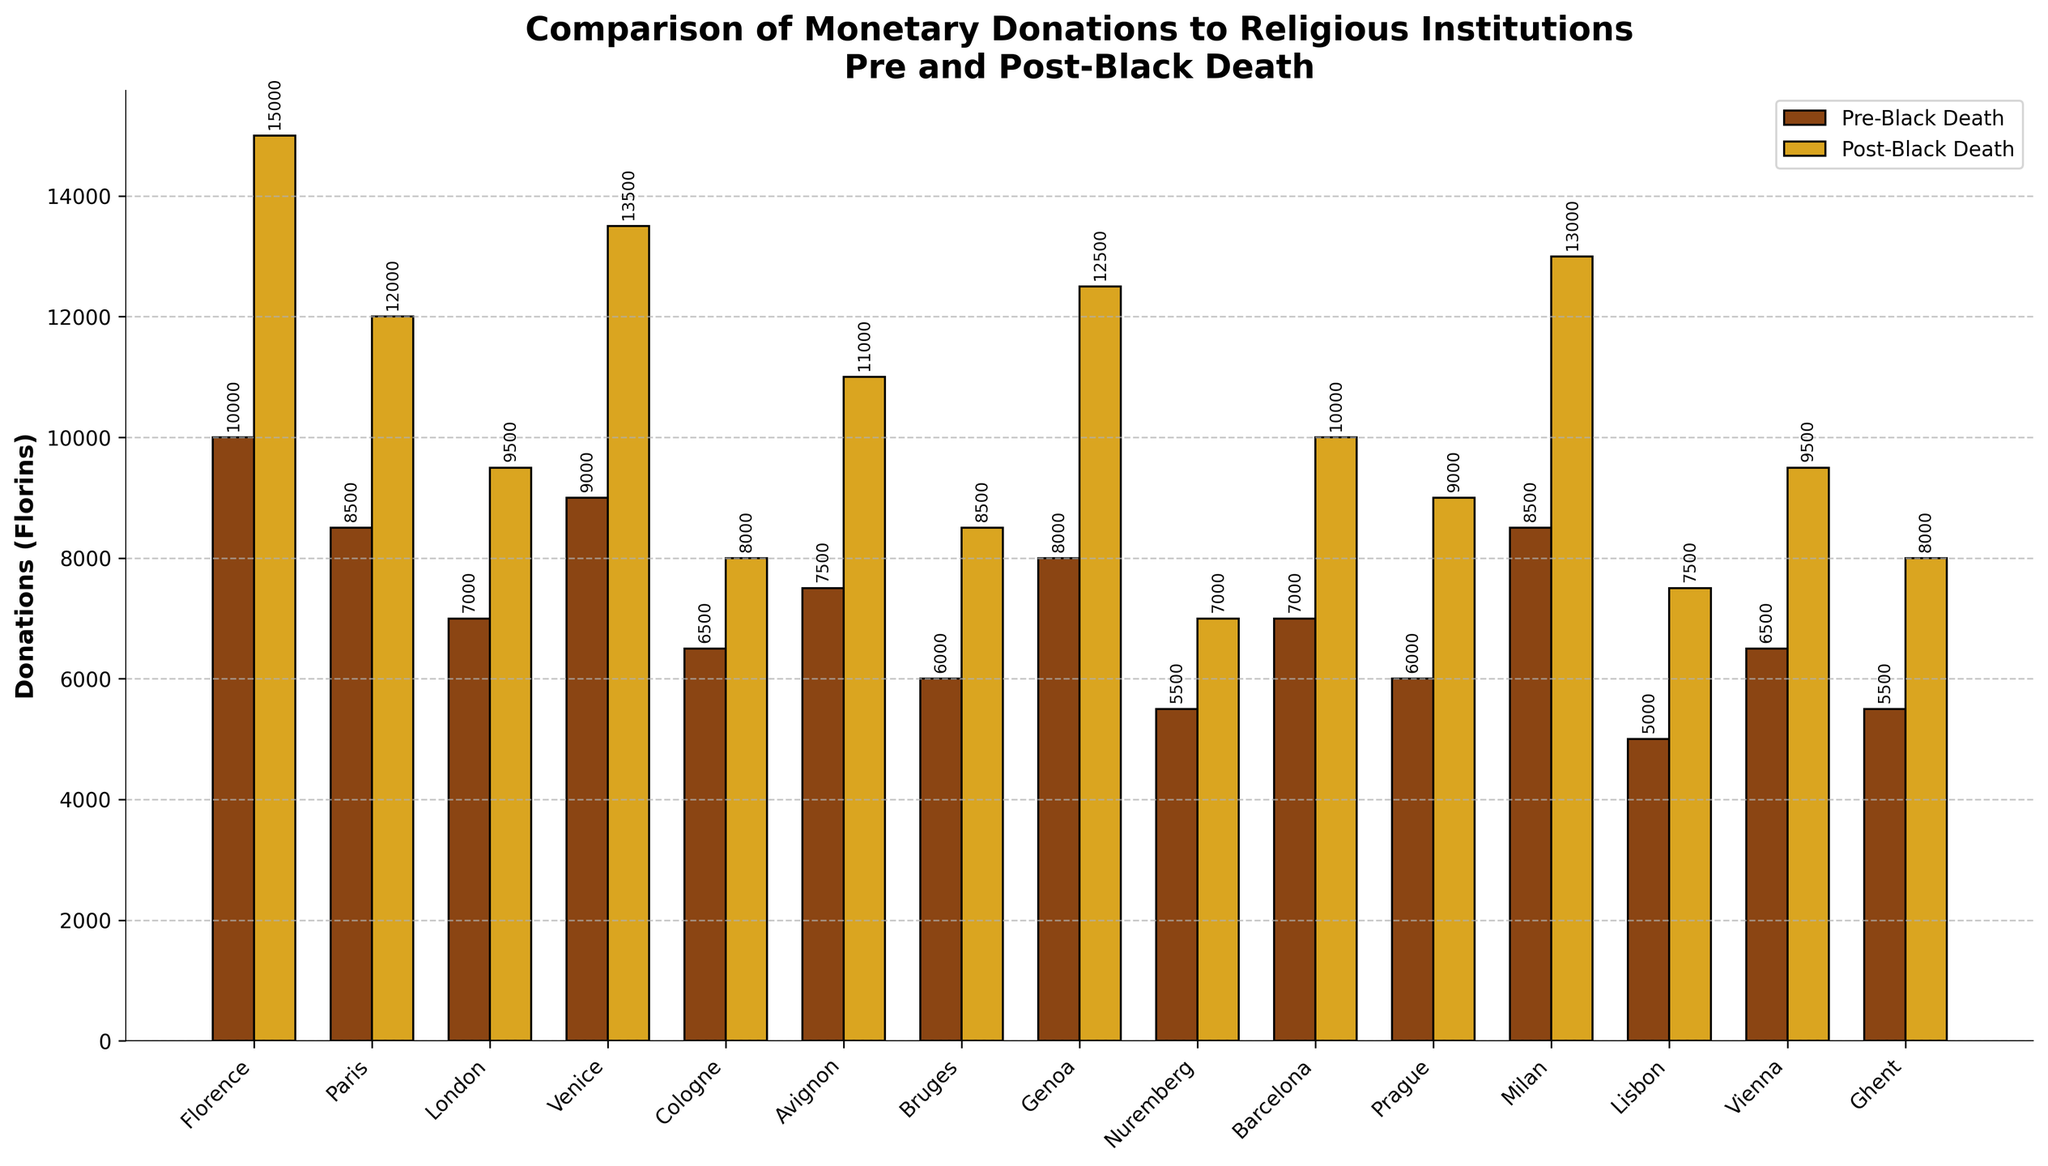What is the difference in donations for Florence pre and post-Black Death? Locate the bar heights for Florence on the x-axis, find the height of the "Pre-Black Death" bar (10,000 florins) and the "Post-Black Death" bar (15,000 florins), and subtract the pre amount from the post amount: 15000 - 10000.
Answer: 5000 florins Which city shows the highest increase in donations post-Black Death? For this, check each city's pre and post bar values and calculate the difference for all cities. The highest difference is in Venice, where the pre value is 9000 florins and post value is 13500 florins: difference is 13500 - 9000.
Answer: Venice How many cities have donations post-Black Death exceeding 10,000 florins? Identify all bars labelled "Post-Black Death" that exceed the 10,000 line on the y-axis. The cities are Florence, Paris, Venice, Avignon, Genoa, Milan, and Vienna.
Answer: Seven cities What is the average donation amount post-Black Death for all cities? Add up all the "Post-Black Death" bar values (15000 + 12000 + 9500 + 13500 + 8000 + 11000 + 8500 + 12500 + 7000 + 10000 + 9000 + 13000 + 7500 + 9500 + 8000) and divide by the number of cities (15). Total is 155,000, average: 155000 / 15.
Answer: 10333.33 florins Which city shows the smallest increase in donations post-Black Death? Compare the differences (post minus pre) for each city. The smallest increase is in Cologne, where pre is 6500 florins and post is 8000 florins: difference is 8000 - 6500.
Answer: Cologne Which city has the smallest donation amount pre-Black Death? Look for the shortest bar in the "Pre-Black Death" category. The shortest bar is Lisbon with 5000 florins.
Answer: Lisbon What is the total donation increase for London from pre to post-Black Death? Identify the bar heights for London on the x-axis, pre value is 7000 florins, post value is 9500 florins, and subtract pre value from post value: 9500 - 7000.
Answer: 2500 florins What is the difference in donation values between Paris post-Black Death and Milan pre-Black Death? Locate the bar heights, Paris post value is 12000 florins, Milan pre value is 8500 florins, and subtract Milan value from Paris value: 12000 - 8500.
Answer: 3500 florins How many cities have donations that increased by at least 3000 florins post-Black Death? Calculate the differences for all cities, and count how many have a difference of 3000 florins or more. Florence (5000), Paris (3500), Venice (4500), Avignon (3500), Genoa (4500), Milan (4500), Prague (3000), Barcelona (3000), Lisbon (2500), Vienna (3000). There are 8 cities satisfying this condition.
Answer: Eight cities 